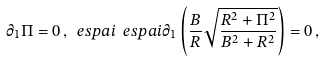<formula> <loc_0><loc_0><loc_500><loc_500>\partial _ { 1 } \Pi = 0 \, , \ e s p a i \ e s p a i \partial _ { 1 } \left ( \frac { B } { R } \sqrt { \frac { R ^ { 2 } + \Pi ^ { 2 } } { B ^ { 2 } + R ^ { 2 } } } \right ) = 0 \, ,</formula> 